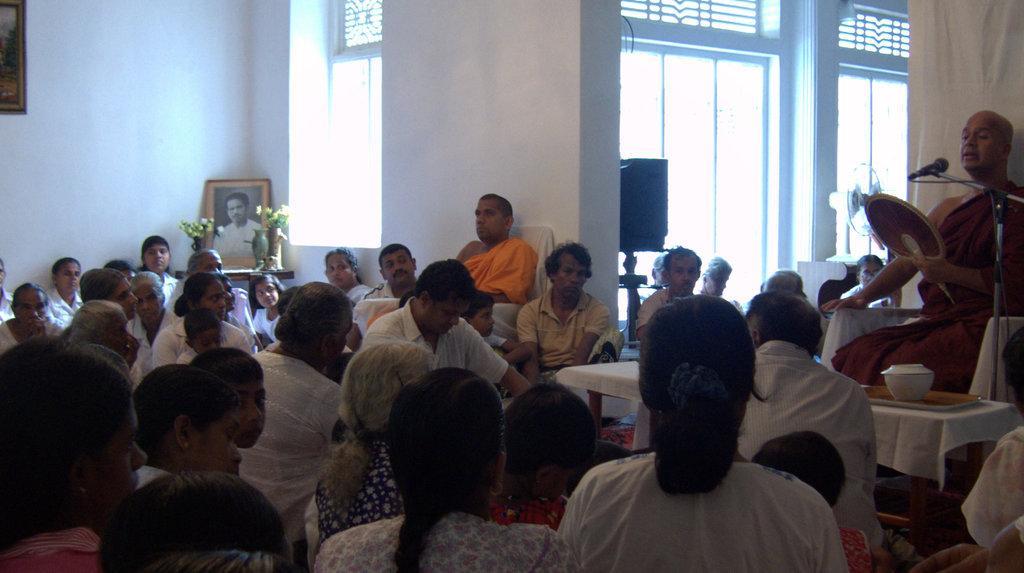In one or two sentences, can you explain what this image depicts? The image is inside the room. In the image there are group of people sitting, on right side there is a man sitting on chair talking in front of a microphone. On left side there is a table, on table we can see a photo frame and a flower pot in background we can see photo frames on wall,speakers,glass window and a wall which is in white color. 